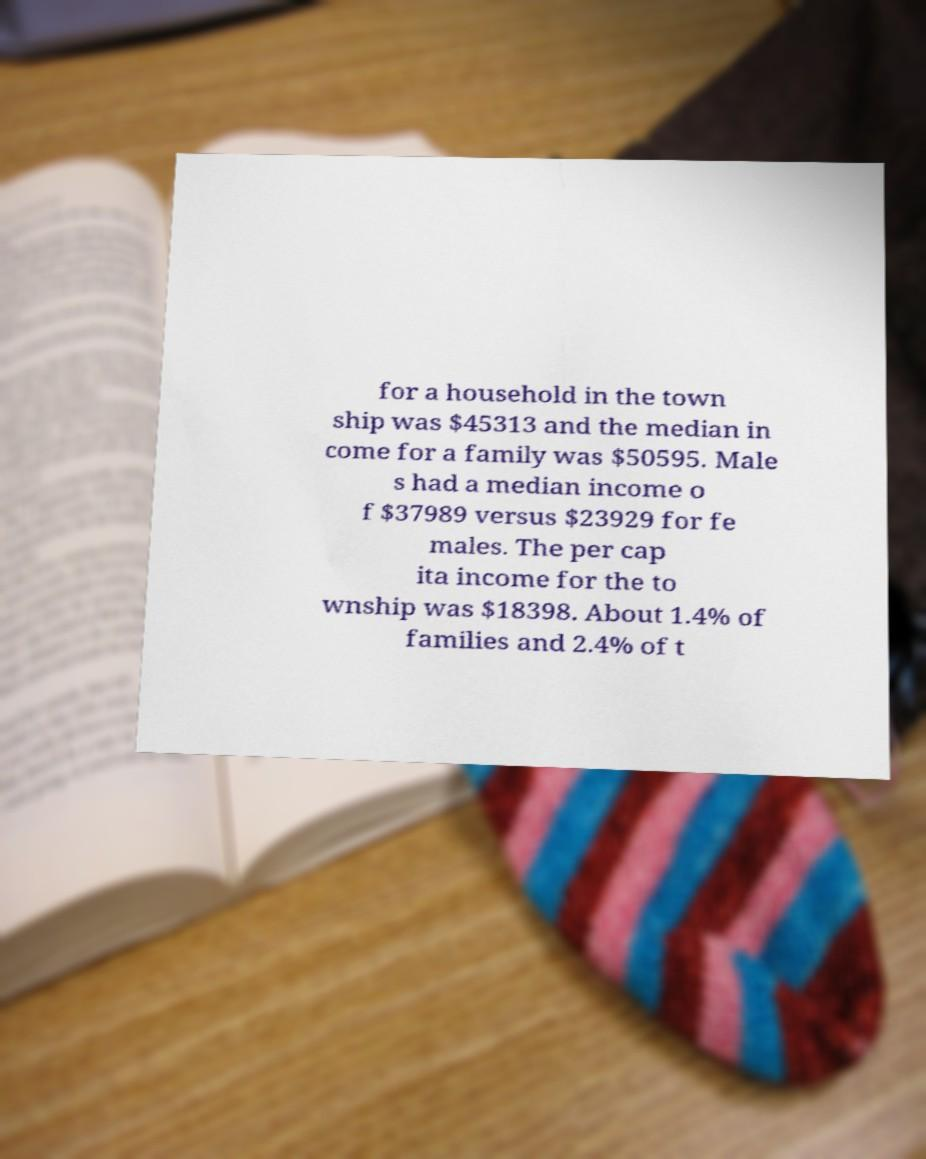What messages or text are displayed in this image? I need them in a readable, typed format. for a household in the town ship was $45313 and the median in come for a family was $50595. Male s had a median income o f $37989 versus $23929 for fe males. The per cap ita income for the to wnship was $18398. About 1.4% of families and 2.4% of t 